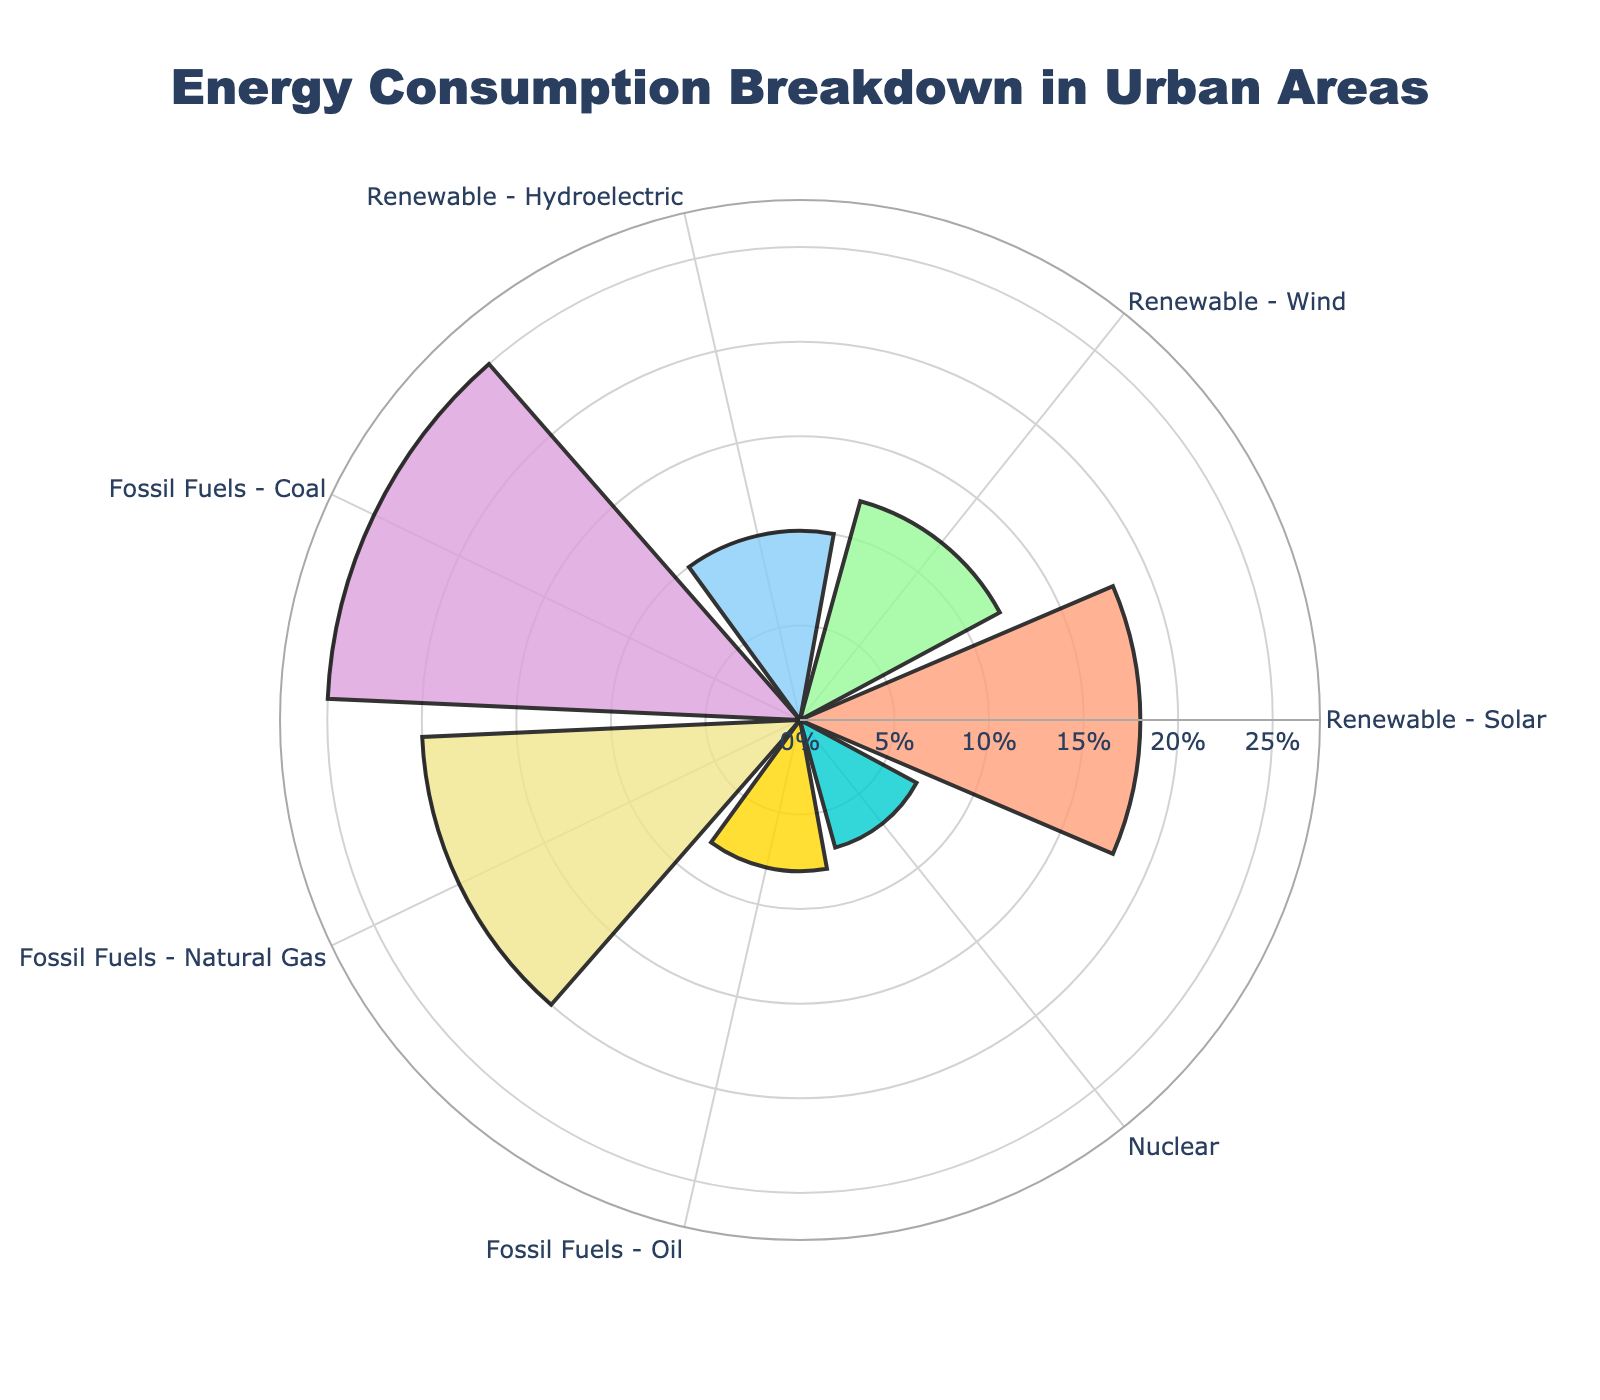What is the title of the chart? The title is displayed at the top of the chart. It reads "Energy Consumption Breakdown in Urban Areas".
Answer: Energy Consumption Breakdown in Urban Areas What is the largest energy source in the chart? The source with the longest bar and highest value on the radial axis is "Fossil Fuels - Coal" with 25%.
Answer: Fossil Fuels - Coal How much percentage is consumed by renewable energy sources in total? The renewable sources are Solar, Wind, and Hydroelectric. Add their percentages: 18% + 12% + 10% = 40%.
Answer: 40% Which energy source has the smallest share? The source with the shortest bar and smallest value on the radial axis is "Nuclear" with 7%.
Answer: Nuclear What is the difference in percentage between Coal and Natural Gas consumption? Find the percentages of Coal (25%) and Natural Gas (20%), then subtract the smaller from the larger: 25% - 20% = 5%.
Answer: 5% How many energy sources are represented in the chart? Count the distinct segments in the polar area chart, which correspond to the number of sources. There are 7 sources represented.
Answer: 7 Which renewable energy source has the highest percentage and what is it? Among the renewable sources, Solar has the highest percentage with 18%.
Answer: Renewable - Solar, 18% How does the consumption of Natural Gas compare to the combined consumption of Wind and Hydroelectric? The percentage for Natural Gas is 20%. Sum Wind and Hydroelectric percentages: 12% + 10% = 22%. Natural Gas (20%) is less than the combined Wind and Hydroelectric (22%).
Answer: Less What is the combined percentage of Fossil Fuels sources? The Fossil Fuels sources are Coal, Natural Gas, and Oil. Add their percentages: 25% + 20% + 8% = 53%.
Answer: 53% What is the average percentage consumption across all sources? Sum all the percentages and divide by the number of sources: (18 + 12 + 10 + 25 + 20 + 8 + 7)/7 = 14.29%.
Answer: 14.29% 